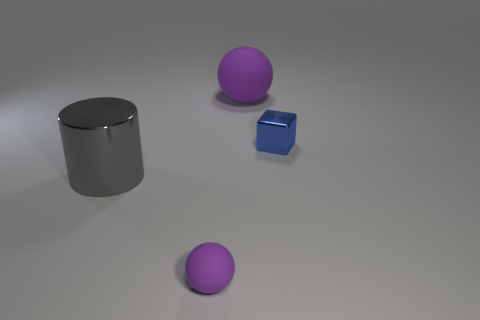Are there any gray metal things to the right of the small purple matte thing?
Provide a short and direct response. No. What is the color of the tiny object that is made of the same material as the big ball?
Provide a short and direct response. Purple. Is the color of the sphere that is in front of the gray shiny thing the same as the large object that is on the right side of the gray shiny object?
Provide a succinct answer. Yes. What number of spheres are large gray metallic objects or blue shiny objects?
Make the answer very short. 0. Are there an equal number of tiny blocks to the right of the blue metal thing and small purple things?
Ensure brevity in your answer.  No. What material is the big thing to the left of the matte sphere that is to the right of the tiny ball left of the blue metallic object?
Offer a very short reply. Metal. What material is the sphere that is the same color as the large matte thing?
Offer a very short reply. Rubber. What number of things are matte things that are behind the tiny matte object or small purple cubes?
Provide a short and direct response. 1. What number of objects are yellow spheres or small things to the right of the large purple rubber ball?
Provide a succinct answer. 1. What number of tiny blue blocks are right of the purple matte thing in front of the shiny object right of the big shiny object?
Ensure brevity in your answer.  1. 